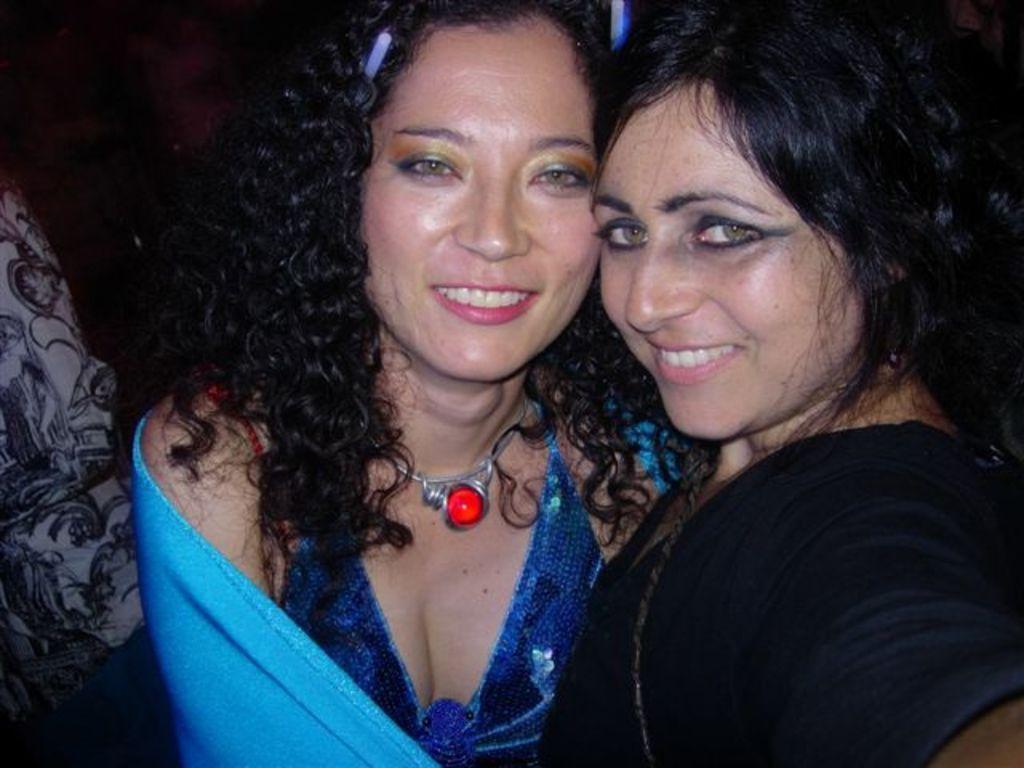Could you give a brief overview of what you see in this image? There are two ladies. Both are smiling. Lady in the center is wearing a necklace with red stone. 